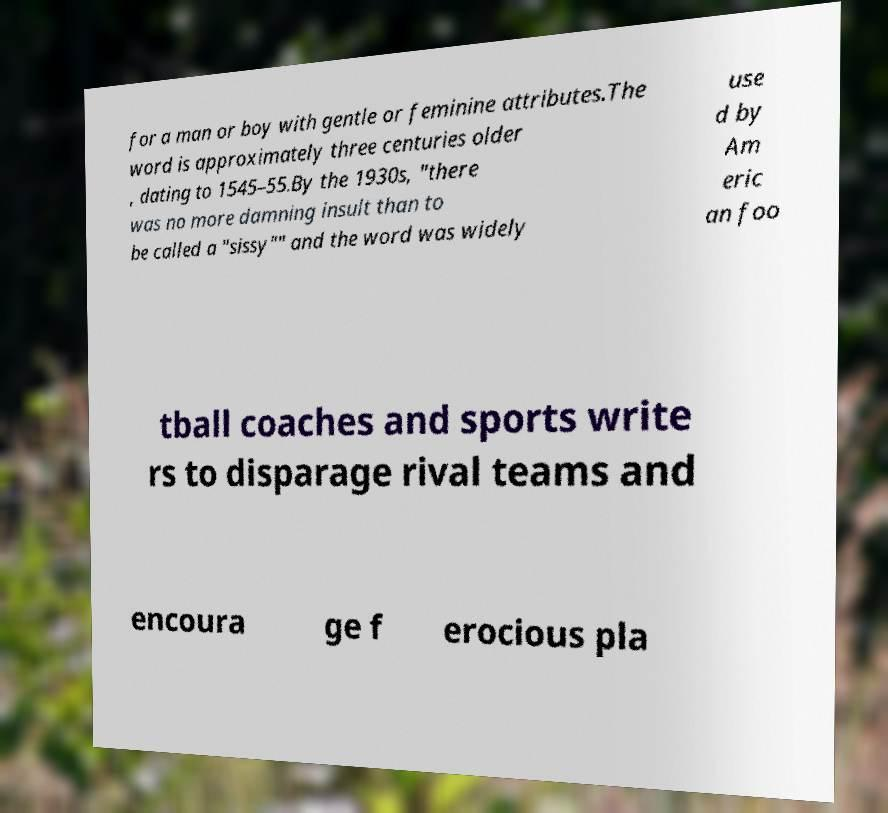For documentation purposes, I need the text within this image transcribed. Could you provide that? for a man or boy with gentle or feminine attributes.The word is approximately three centuries older , dating to 1545–55.By the 1930s, "there was no more damning insult than to be called a "sissy"" and the word was widely use d by Am eric an foo tball coaches and sports write rs to disparage rival teams and encoura ge f erocious pla 